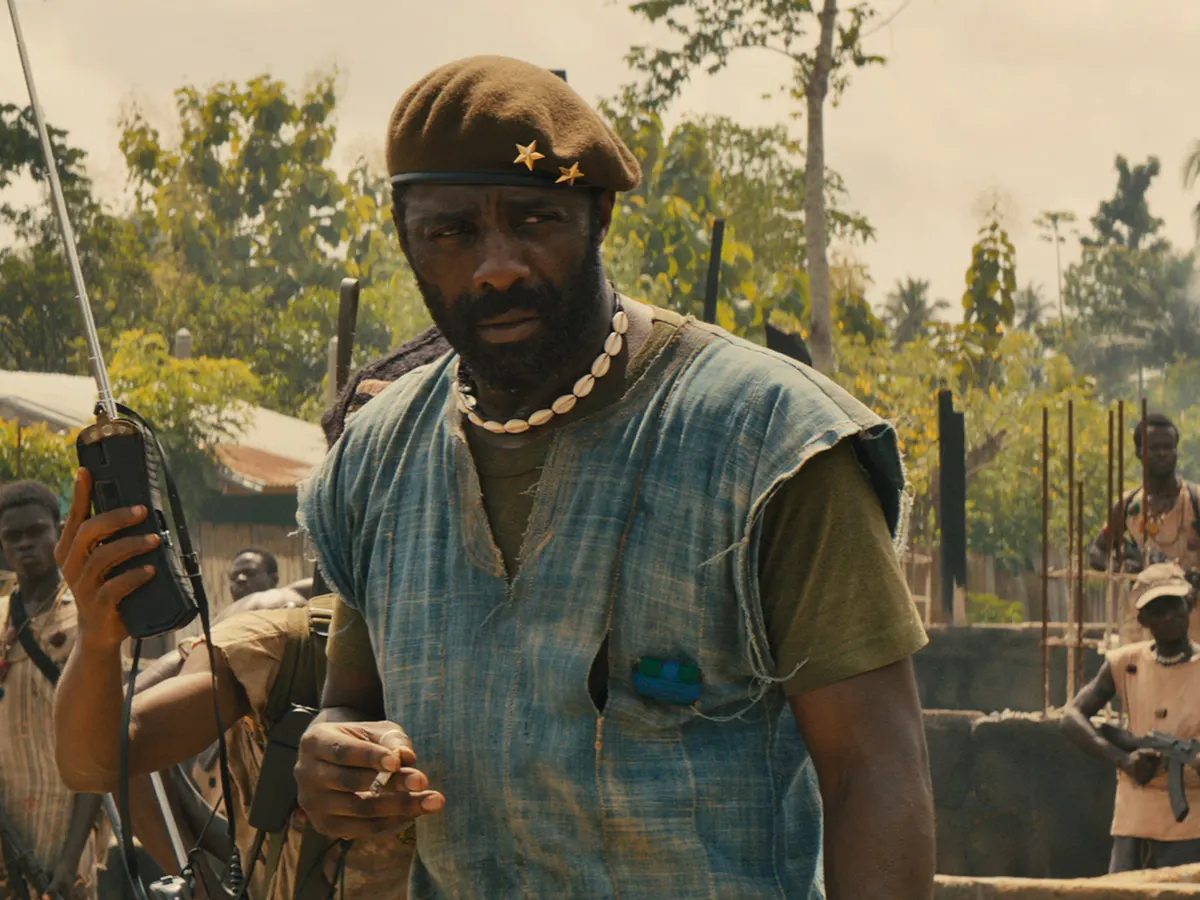What are the emotional undertones of this image, and how do they contribute to the narrative of the film? The emotional undertones of this image portray a blend of stern authority and the weight of responsibility. Idris Elba's character, Commandant, exudes dominance and control, essential for leading his faction in a war-torn region. Yet, there are subtle hints of the heavy burden he carries, evident in his focussed yet somber expression. These emotions deepen the character’s complexity and add layers to the narrative of the film, illustrating the human side of leadership amidst chaos and violence. The submissive posture of the soldiers around him underscores the hierarchy and the dire circumstances they face. Can you describe the visual details and symbolism in the character’s attire? The Commandant’s attire is laden with symbolism reflective of his role and the environment. His blue sleeveless shirt juxtaposed with a green vest speaks to a makeshift ruggedness, indicative of a life constantly on the move in war zones. The green beret, adorned with a gold star, symbolizes leadership and rank, a visual cue of his authority within the militant group. The walkie-talkie in his right hand signifies the importance of communication and command in guerrilla warfare. The gun slung over his shoulder epitomizes the perpetual readiness for combat. Together, these elements paint a vivid picture of a leader bound by duty and the perpetual intricacies of a combat-driven existence. 